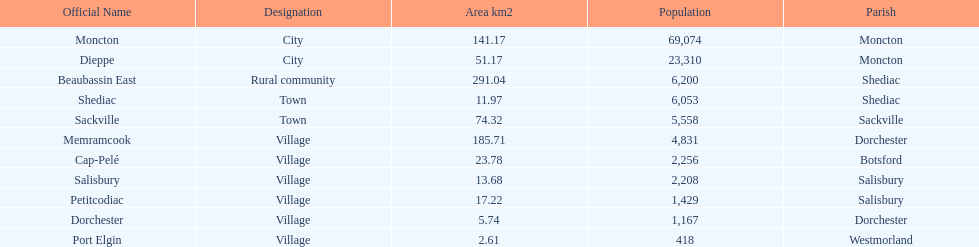In which city is the area smallest? Port Elgin. 